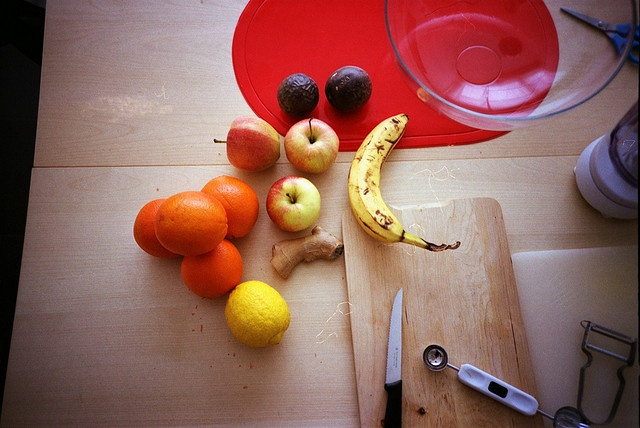Describe the objects in this image and their specific colors. I can see bowl in black, brown, and gray tones, orange in black, maroon, and red tones, banana in black, khaki, tan, and brown tones, apple in black, brown, red, and tan tones, and orange in black, olive, gold, orange, and yellow tones in this image. 